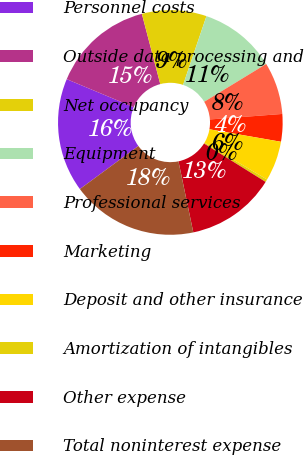<chart> <loc_0><loc_0><loc_500><loc_500><pie_chart><fcel>Personnel costs<fcel>Outside data processing and<fcel>Net occupancy<fcel>Equipment<fcel>Professional services<fcel>Marketing<fcel>Deposit and other insurance<fcel>Amortization of intangibles<fcel>Other expense<fcel>Total noninterest expense<nl><fcel>16.4%<fcel>14.62%<fcel>9.29%<fcel>11.07%<fcel>7.51%<fcel>3.96%<fcel>5.73%<fcel>0.4%<fcel>12.84%<fcel>18.18%<nl></chart> 